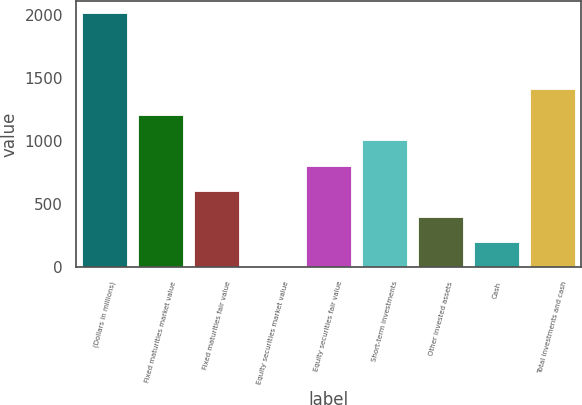Convert chart to OTSL. <chart><loc_0><loc_0><loc_500><loc_500><bar_chart><fcel>(Dollars in millions)<fcel>Fixed maturities market value<fcel>Fixed maturities fair value<fcel>Equity securities market value<fcel>Equity securities fair value<fcel>Short-term investments<fcel>Other invested assets<fcel>Cash<fcel>Total investments and cash<nl><fcel>2014<fcel>1208.72<fcel>604.76<fcel>0.8<fcel>806.08<fcel>1007.4<fcel>403.44<fcel>202.12<fcel>1410.04<nl></chart> 